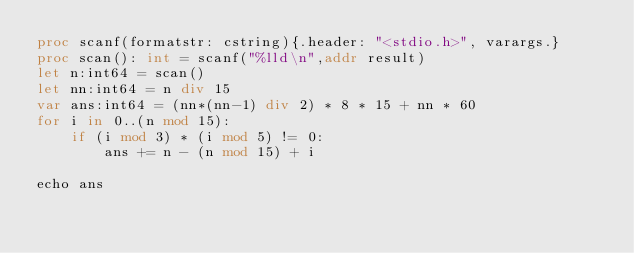Convert code to text. <code><loc_0><loc_0><loc_500><loc_500><_Nim_>proc scanf(formatstr: cstring){.header: "<stdio.h>", varargs.}
proc scan(): int = scanf("%lld\n",addr result)
let n:int64 = scan()
let nn:int64 = n div 15
var ans:int64 = (nn*(nn-1) div 2) * 8 * 15 + nn * 60
for i in 0..(n mod 15):
    if (i mod 3) * (i mod 5) != 0:
        ans += n - (n mod 15) + i

echo ans</code> 